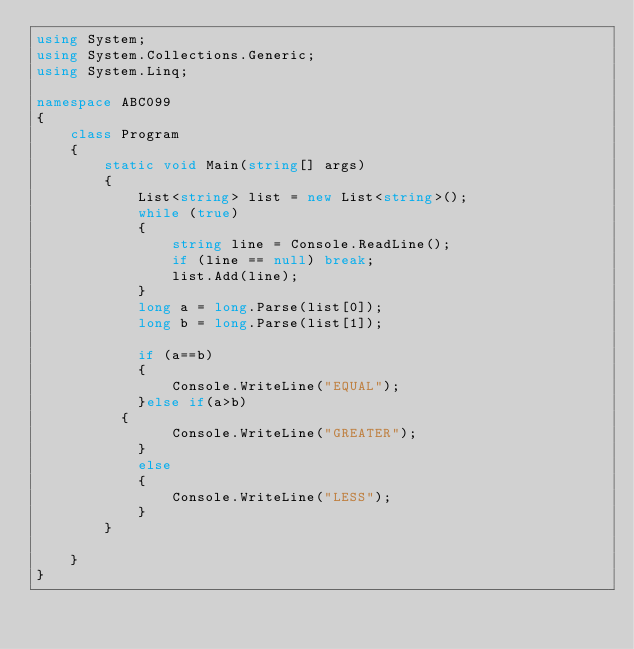<code> <loc_0><loc_0><loc_500><loc_500><_C#_>using System;
using System.Collections.Generic;
using System.Linq;

namespace ABC099
{
    class Program
    {
        static void Main(string[] args)
        {
            List<string> list = new List<string>();
            while (true)
            {
                string line = Console.ReadLine();
                if (line == null) break;
                list.Add(line);
            }
            long a = long.Parse(list[0]);
            long b = long.Parse(list[1]);

            if (a==b)
            {
                Console.WriteLine("EQUAL");
            }else if(a>b)
	        {
                Console.WriteLine("GREATER");
            }
            else
            {
                Console.WriteLine("LESS");
            }
        }

    }
}
</code> 